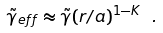Convert formula to latex. <formula><loc_0><loc_0><loc_500><loc_500>\tilde { \gamma } _ { e f f } \approx \tilde { \gamma } ( r / a ) ^ { 1 - K } \ .</formula> 